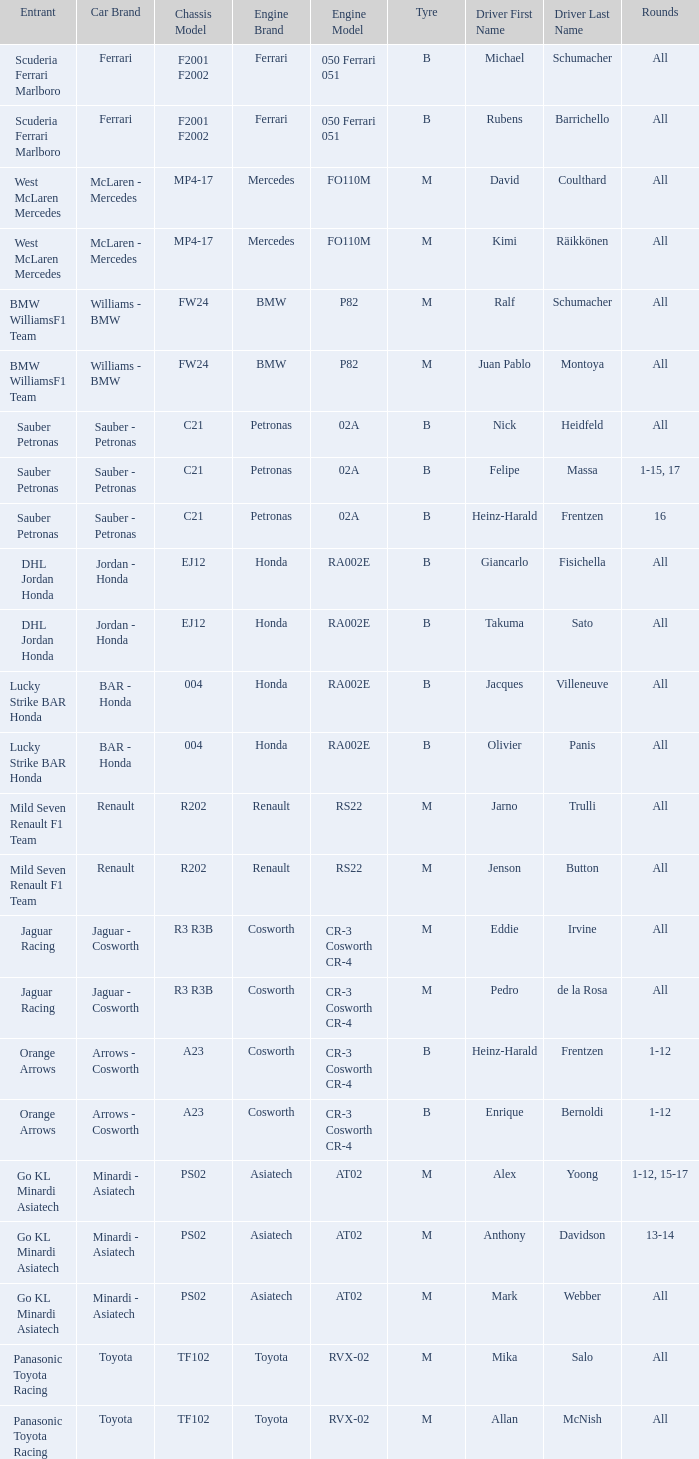What is the engine when the rounds ar all, the tyre is m and the driver is david coulthard? Mercedes FO110M. 